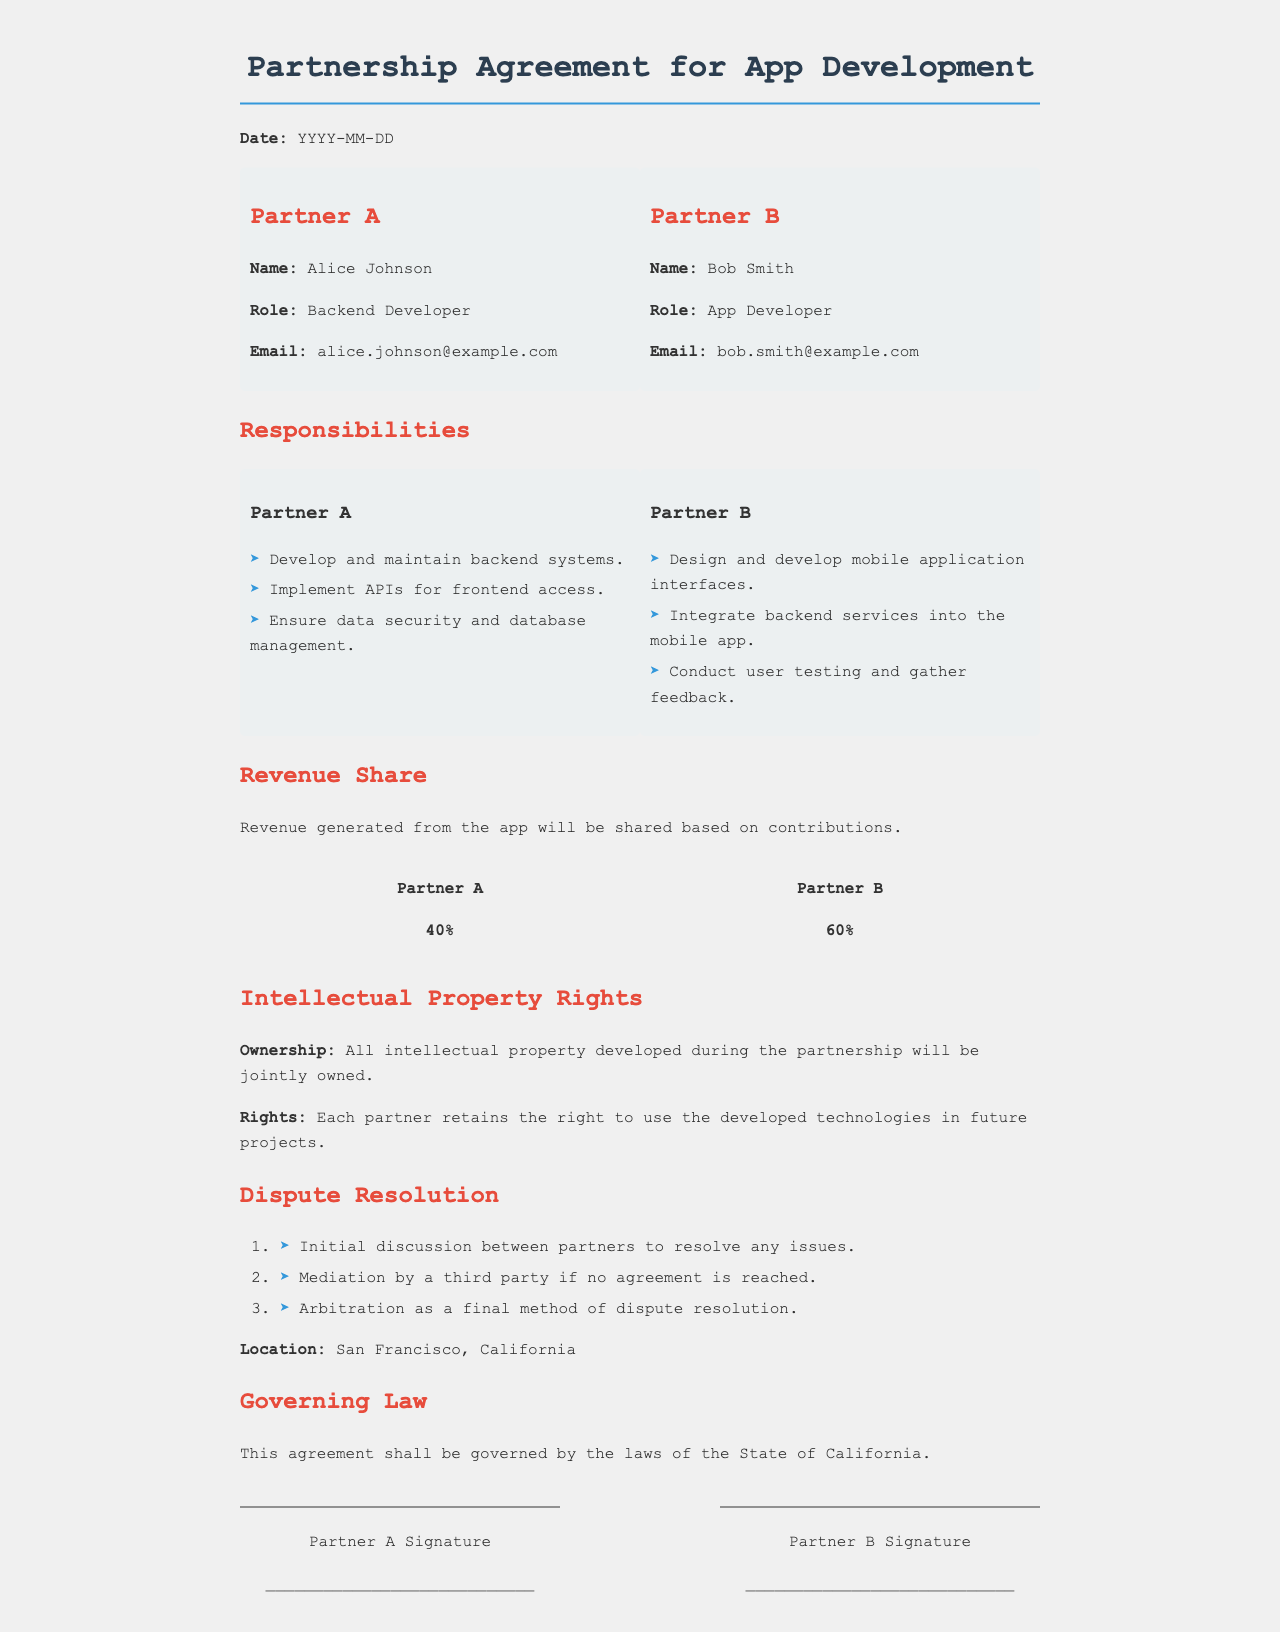What is the name of Partner A? Partner A's name is listed as Alice Johnson in the document.
Answer: Alice Johnson What percentage of revenue does Partner B receive? The document states that Partner B receives 60% of the revenue generated from the app.
Answer: 60% What role does Partner A have? The document specifies that Partner A's role is Backend Developer.
Answer: Backend Developer How will intellectual property be owned according to the agreement? The document indicates that all intellectual property developed during the partnership will be jointly owned.
Answer: Jointly owned What is the first step in the dispute resolution process? The first step outlined in the dispute resolution section is an initial discussion between partners to resolve any issues.
Answer: Initial discussion Where is the location for dispute resolution mentioned? The document specifies San Francisco, California as the location for dispute resolution.
Answer: San Francisco, California What are the rights of each partner concerning developed technologies? According to the document, each partner retains the right to use the developed technologies in future projects.
Answer: Use in future projects What is the governing law for the agreement? The governing law specified in the document is the laws of the State of California.
Answer: State of California What is the email address of Partner B? Partner B's email address is provided in the document as bob.smith@example.com.
Answer: bob.smith@example.com 